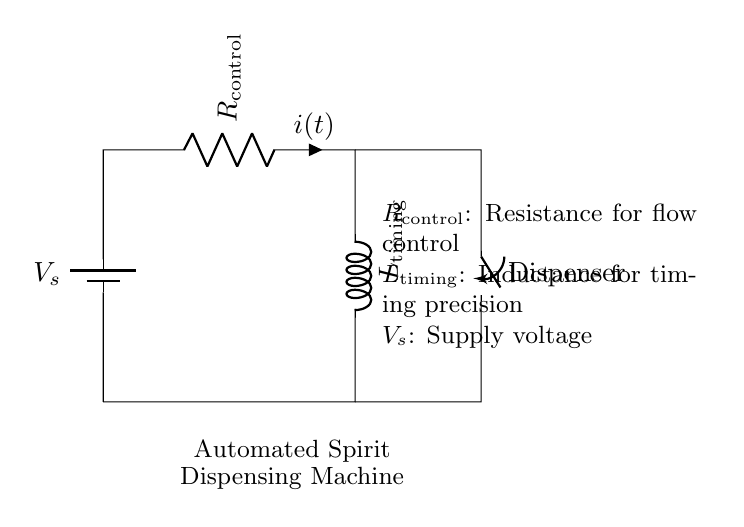What is the supply voltage in the circuit? The supply voltage, denoted as V_s in the circuit diagram, indicates the potential difference provided to the circuit.
Answer: V_s What is the function of the resistor labeled R_control? The resistor labeled R_control is used to control the current flow in the circuit, which ultimately influences the operation of the timing mechanism and fluid dispensing.
Answer: Control current flow What component is responsible for timing precision in the circuit? The inductor labeled L_timing is responsible for timing precision. Inductors store energy in a magnetic field and can influence the timing of when the current reaches a certain level.
Answer: L_timing What type of switch is used in this circuit? The circuit uses a switch labeled as "Dispenser," which presumably controls the operation of the automated spirit dispensing machine when closed.
Answer: Dispenser How is the automated spirit dispensing machine powered? The machine is powered by the voltage source (V_s) connected to the circuit, which supplies electrical energy to the components, including the resistor and inductor for controlling the flow.
Answer: Powered by V_s What happens when the switch labeled Dispenser is closed? When the switch is closed, the circuit is completed, allowing current to flow through the resistor and inductor. This initiates the timing control for the dispensing of spirits based on the resistance and inductance values.
Answer: Current flows through What effect does an increase in R_control have on the circuit's timing? An increase in R_control will generally slow down the current build-up in the circuit due to the higher resistance, resulting in a longer timing period for the inductor to charge and therefore affect the timing for dispensing.
Answer: Slows down timing 